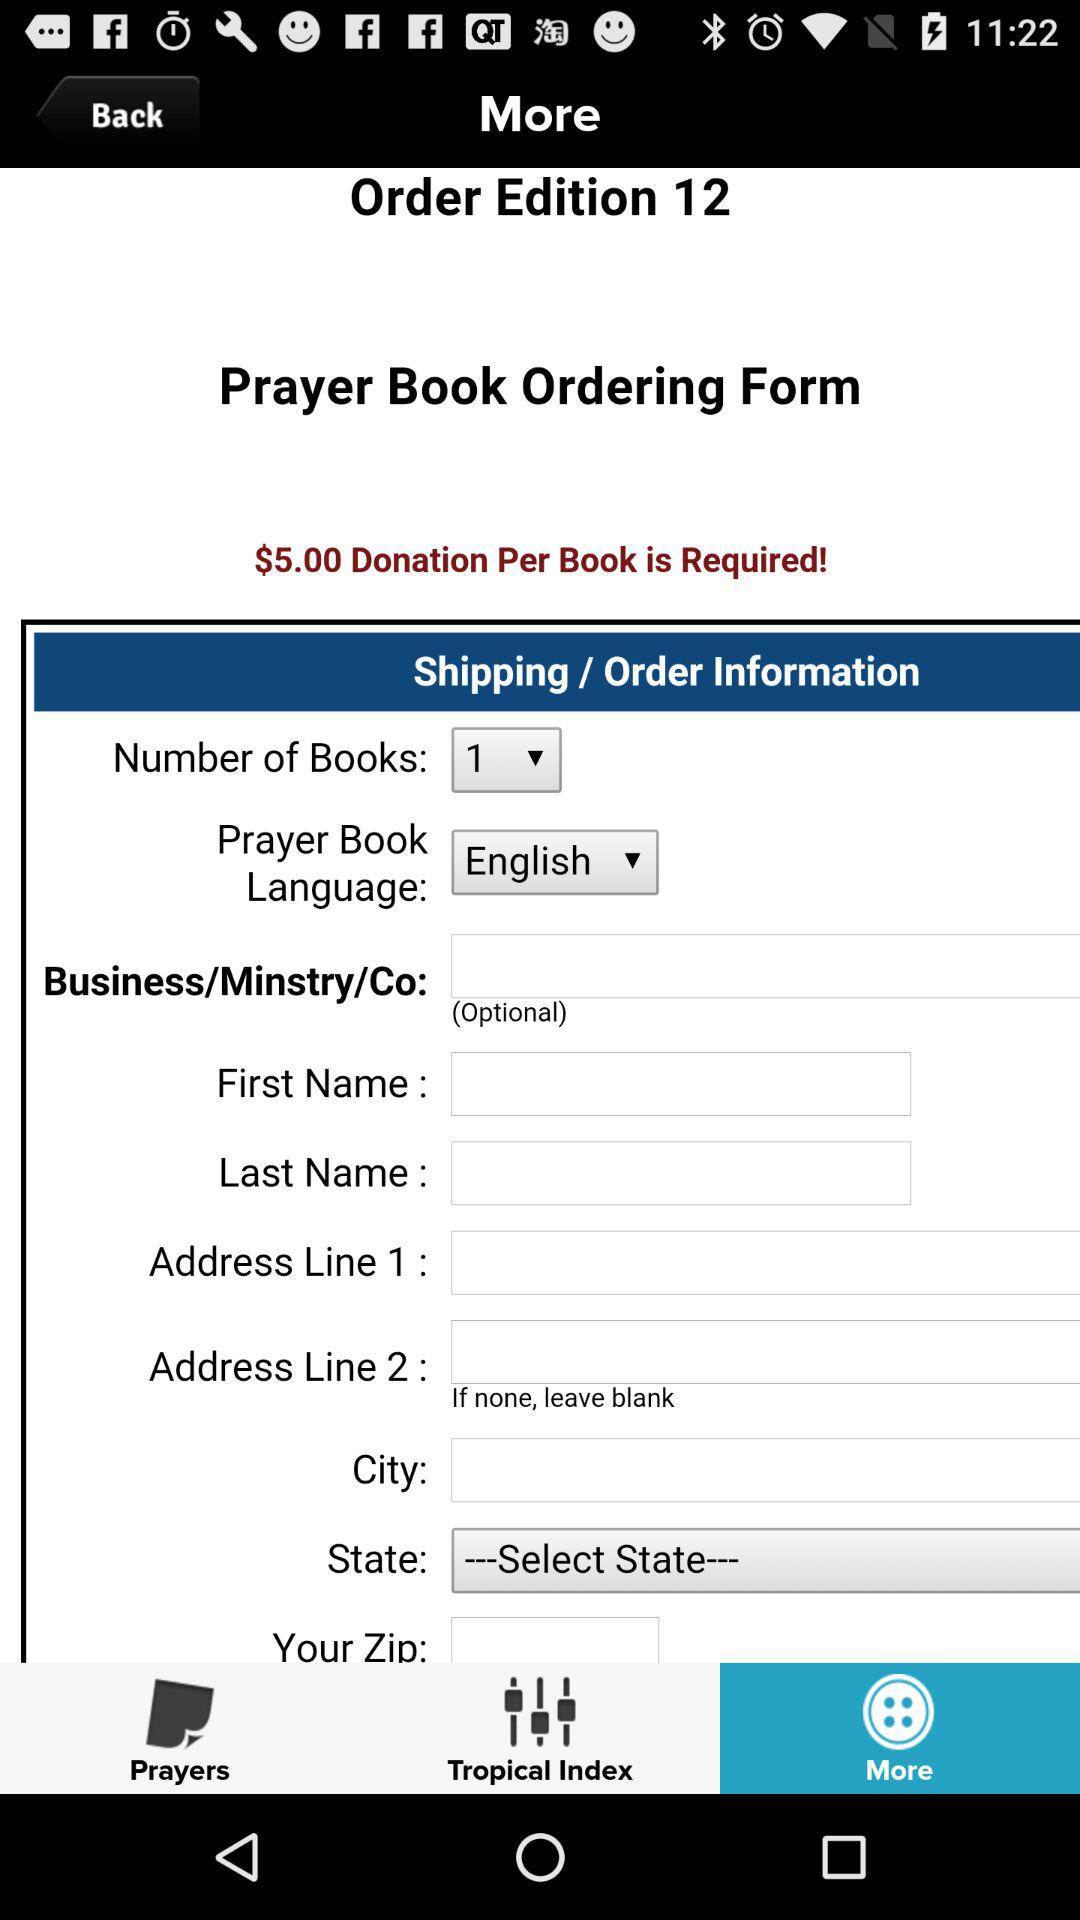How much of a donation is required per book? The required donation is $5 per book. 